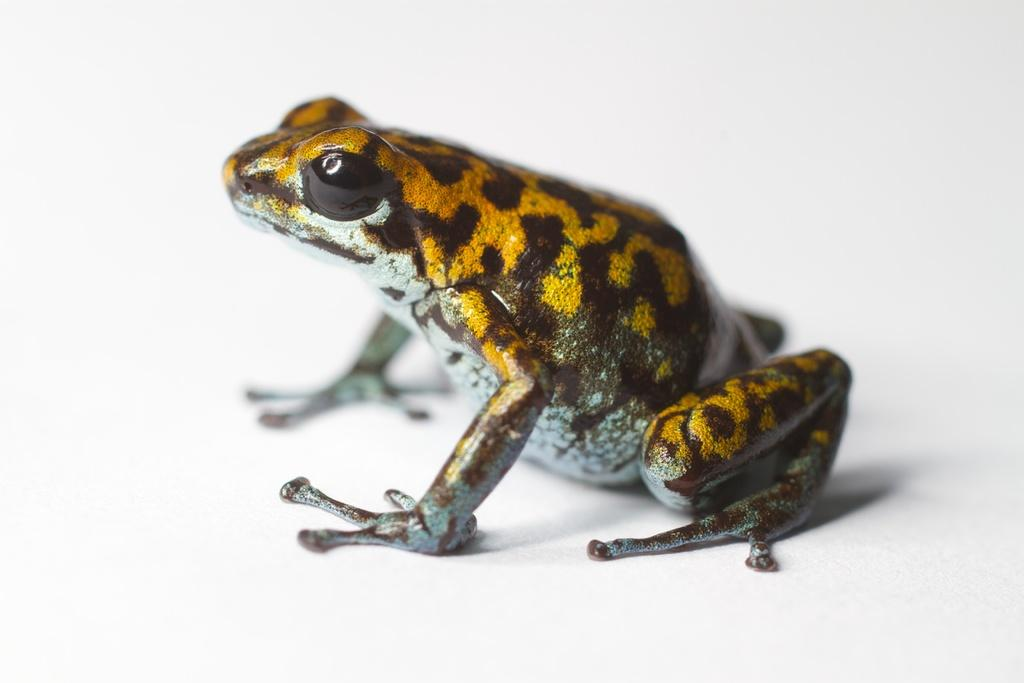What type of animal is in the image? There is an Eastern spadefoot toad in the image. What type of push-up exercise is the toad performing in the image? There is no indication in the image that the toad is performing any push-up exercise. 